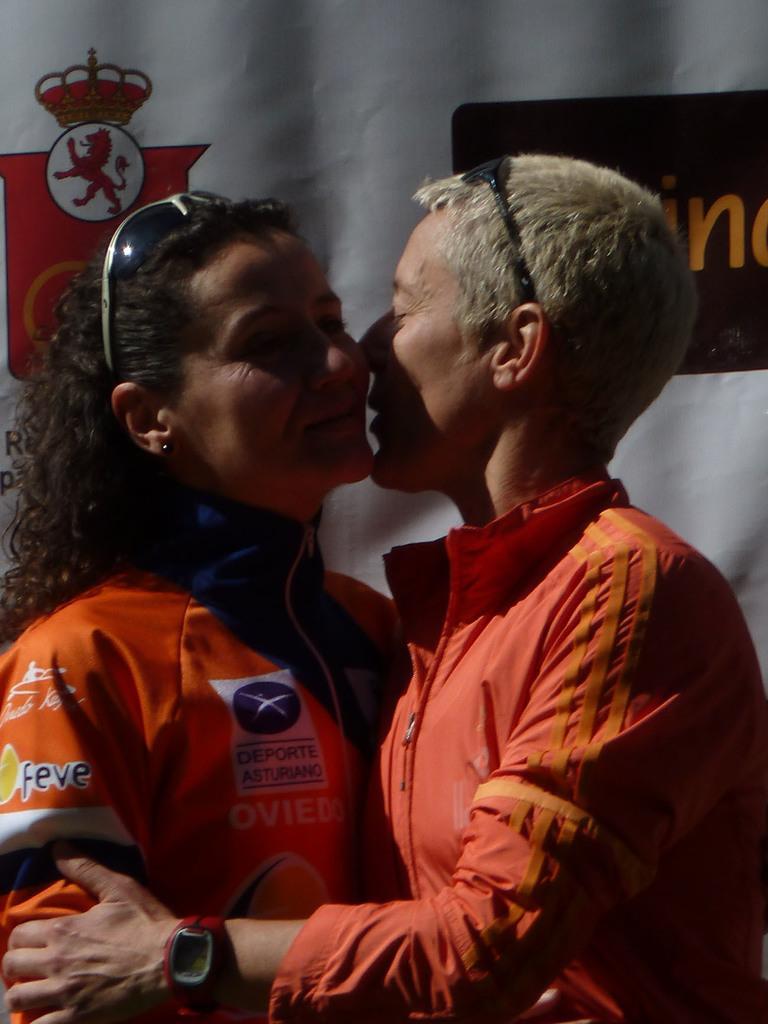In one or two sentences, can you explain what this image depicts? On the left side, there is a woman in an orange color T-shirt, smiling and hugging with another woman who is smiling and holding her hand. In the background, there is a banner. 